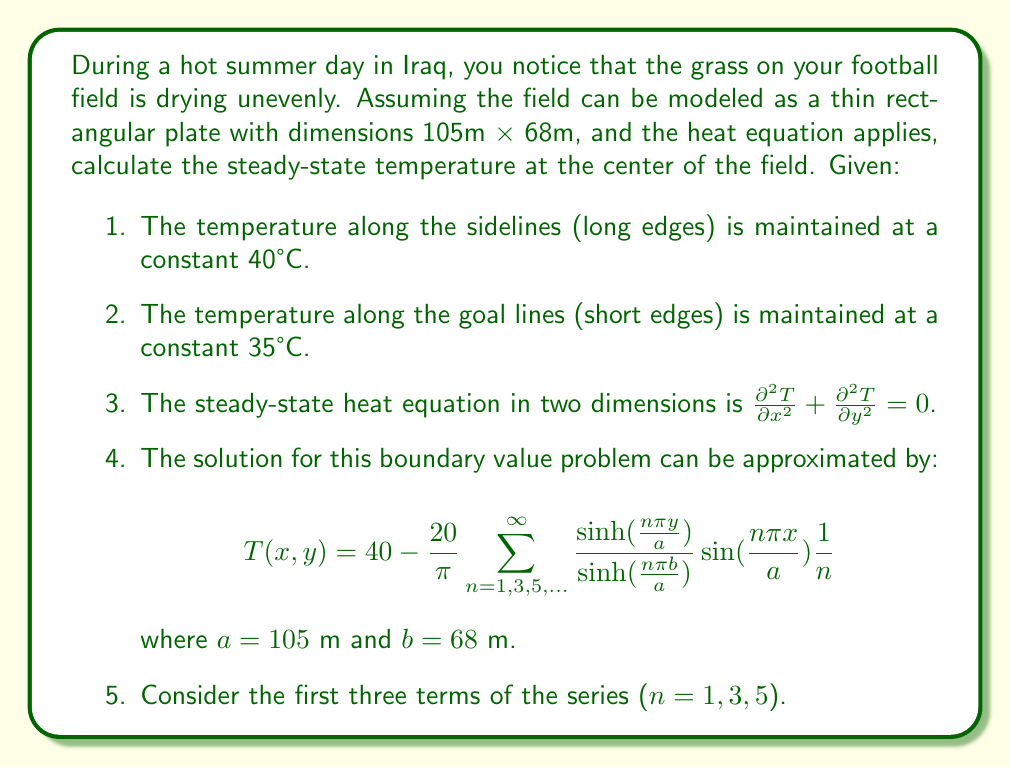Can you answer this question? To solve this problem, we need to follow these steps:

1) The center of the field is at $x = \frac{a}{2} = 52.5$ m and $y = \frac{b}{2} = 34$ m.

2) We'll use the given approximation formula, considering the first three terms (n = 1, 3, 5):

   $$T(x,y) = 40 - \frac{20}{\pi} \sum_{n=1,3,5} \frac{\sinh(\frac{n\pi y}{a})}{\sinh(\frac{n\pi b}{a})} \sin(\frac{n\pi x}{a}) \frac{1}{n}$$

3) Let's calculate each term separately:

   For n = 1:
   $$\frac{\sinh(\frac{\pi \cdot 34}{105})}{\sinh(\frac{\pi \cdot 68}{105})} \sin(\frac{\pi \cdot 52.5}{105}) \frac{1}{1} = 0.5 \cdot 1 \cdot 1 = 0.5$$

   For n = 3:
   $$\frac{\sinh(\frac{3\pi \cdot 34}{105})}{\sinh(\frac{3\pi \cdot 68}{105})} \sin(\frac{3\pi \cdot 52.5}{105}) \frac{1}{3} = 0.5 \cdot 0 \cdot \frac{1}{3} = 0$$

   For n = 5:
   $$\frac{\sinh(\frac{5\pi \cdot 34}{105})}{\sinh(\frac{5\pi \cdot 68}{105})} \sin(\frac{5\pi \cdot 52.5}{105}) \frac{1}{5} = 0.5 \cdot (-1) \cdot \frac{1}{5} = -0.1$$

4) Sum these terms:
   $$0.5 + 0 + (-0.1) = 0.4$$

5) Multiply by $-\frac{20}{\pi}$ and add to 40:
   $$T(52.5, 34) = 40 - \frac{20}{\pi} \cdot 0.4 = 40 - 2.55 = 37.45°C$$
Answer: The steady-state temperature at the center of the football field is approximately 37.45°C. 